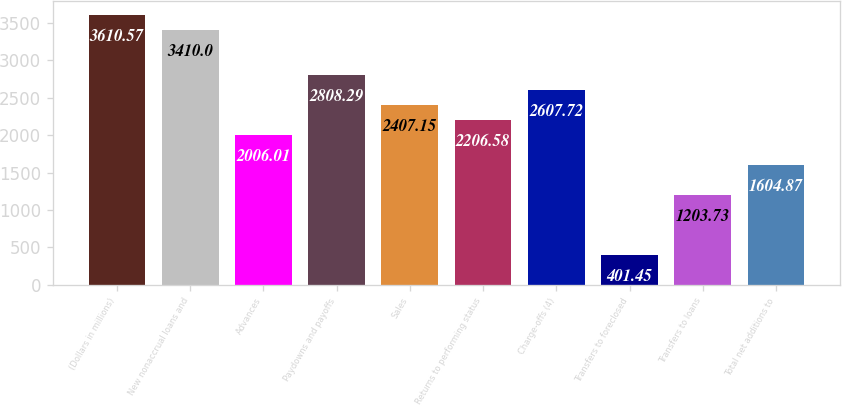Convert chart. <chart><loc_0><loc_0><loc_500><loc_500><bar_chart><fcel>(Dollars in millions)<fcel>New nonaccrual loans and<fcel>Advances<fcel>Paydowns and payoffs<fcel>Sales<fcel>Returns to performing status<fcel>Charge-offs (4)<fcel>Transfers to foreclosed<fcel>Transfers to loans<fcel>Total net additions to<nl><fcel>3610.57<fcel>3410<fcel>2006.01<fcel>2808.29<fcel>2407.15<fcel>2206.58<fcel>2607.72<fcel>401.45<fcel>1203.73<fcel>1604.87<nl></chart> 